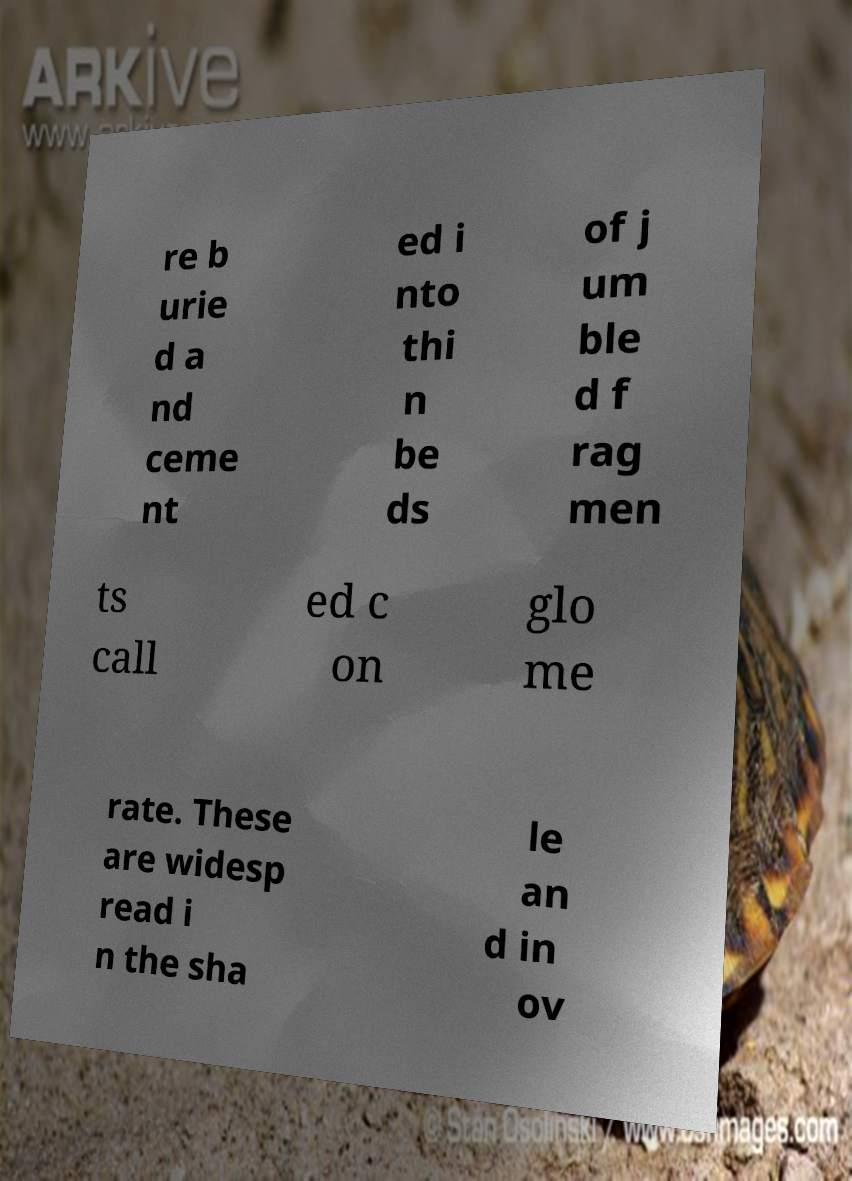Please read and relay the text visible in this image. What does it say? re b urie d a nd ceme nt ed i nto thi n be ds of j um ble d f rag men ts call ed c on glo me rate. These are widesp read i n the sha le an d in ov 